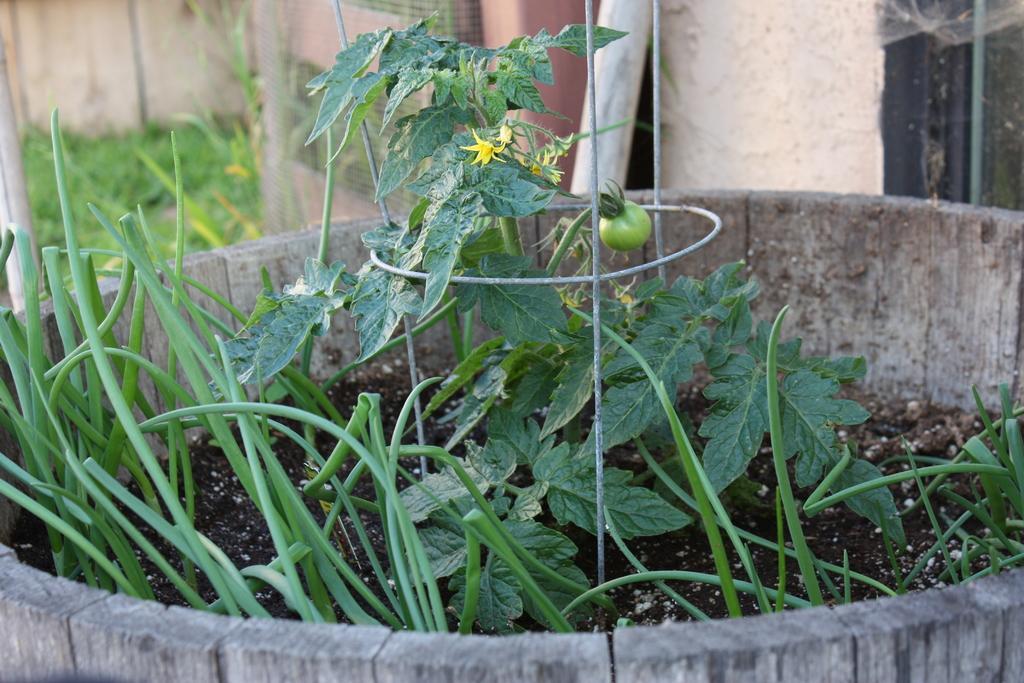Could you give a brief overview of what you see in this image? In this image I can see few plants in a wooden pot. In the background there is a wall and some other objects and also I can see the grass. 